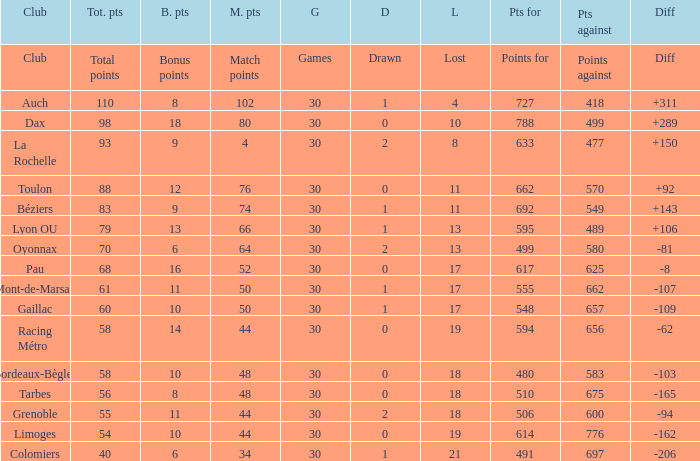What is the diff for a club that has a value of 662 for points for? 92.0. 